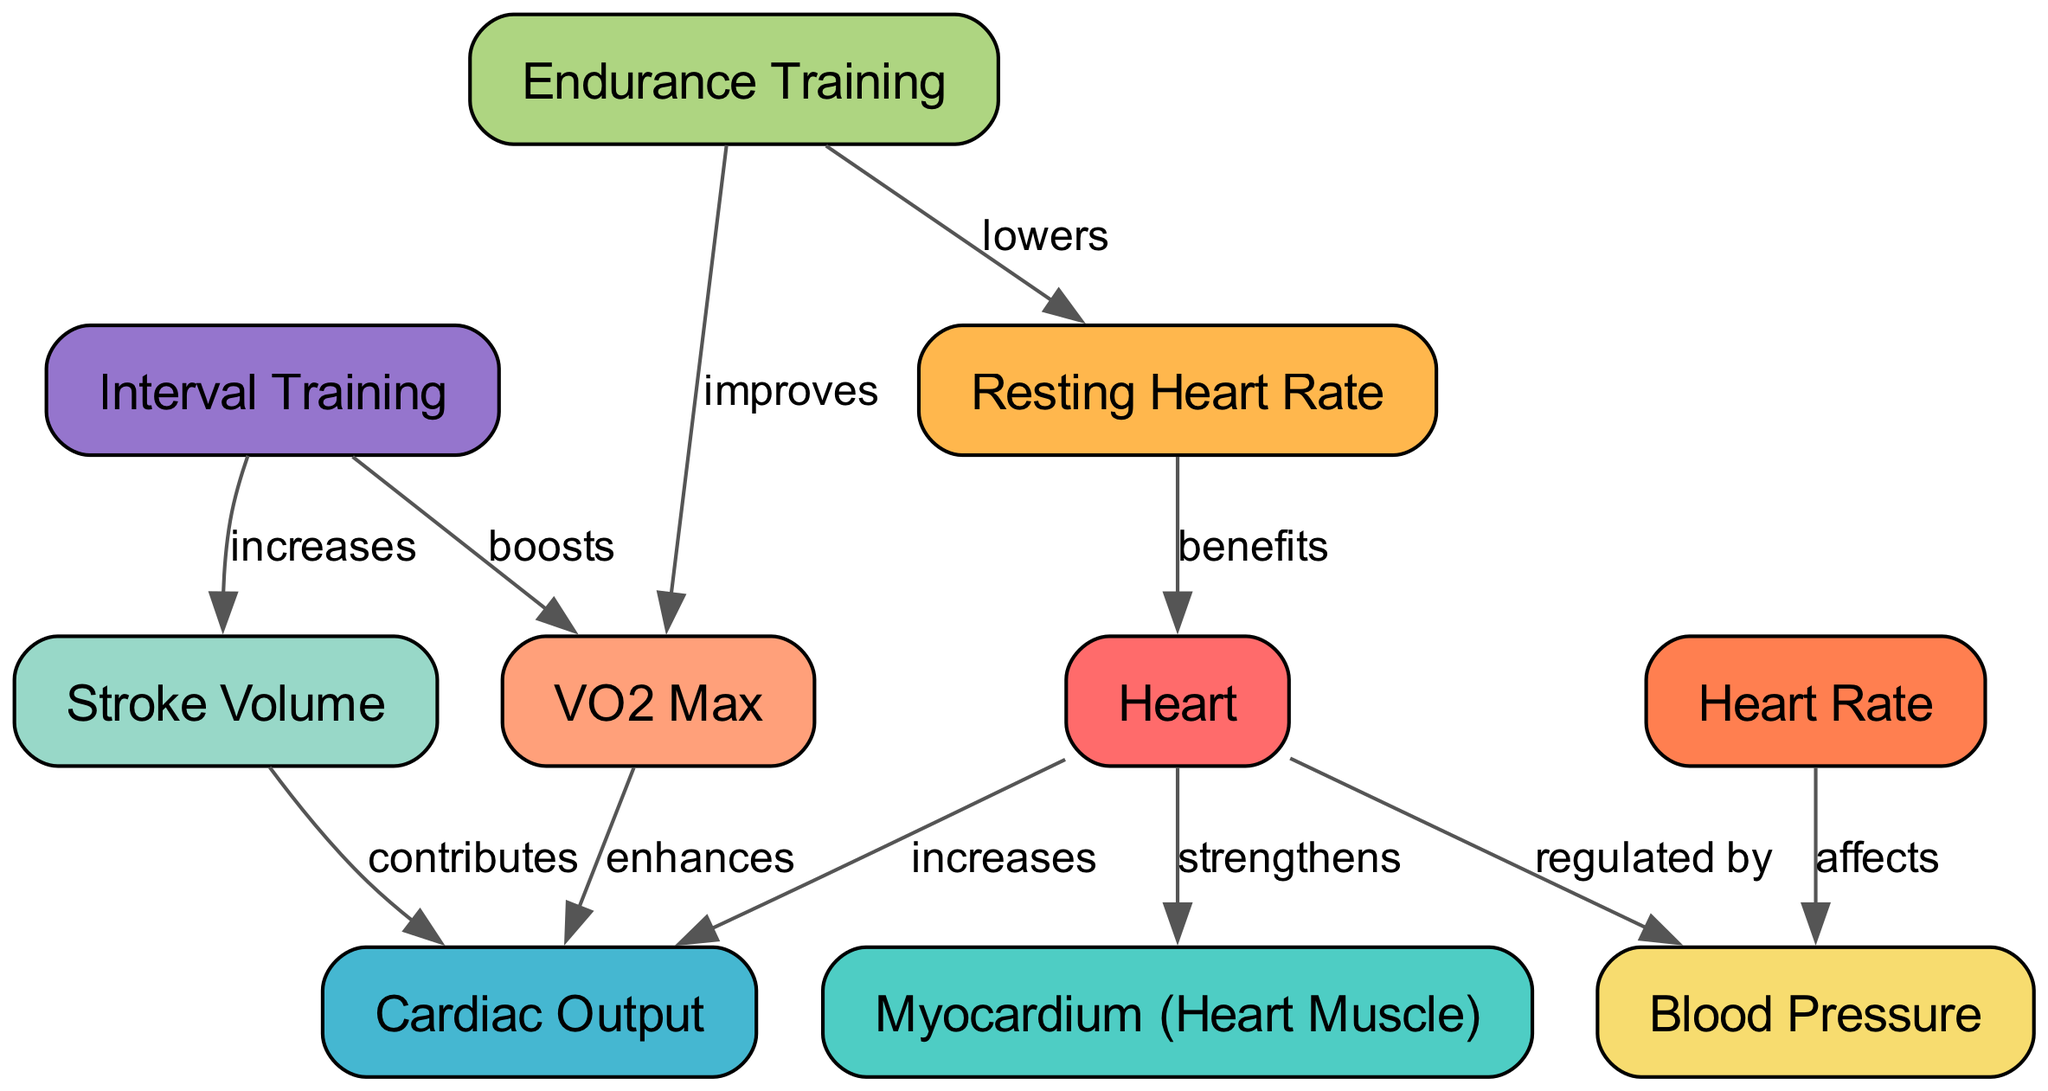What does exercise do to the myocardium? The diagram indicates that the Heart strengthens the Myocardium. So, exercise has a strengthening effect on the heart muscle.
Answer: strengthens How many nodes are present in the diagram? The total number of nodes in the diagram is ten, as we count them from the data provided.
Answer: 10 What impact does endurance training have on VO2 Max? The diagram shows that Endurance Training improves VO2 Max, indicating a positive effect of endurance activities on this measure of fitness.
Answer: improves How does interval training affect stroke volume? The diagram indicates that Interval Training increases Stroke Volume, illustrating that this type of exercise results in a higher volume of blood being pumped per heartbeat.
Answer: increases What is the relationship between heart rate and blood pressure? The diagram indicates that Heart Rate affects Blood Pressure, meaning changes in heart rate can influence blood pressure levels.
Answer: affects What benefits does a lower resting heart rate have? According to the diagram, a lower Resting Heart Rate benefits the Heart, suggesting that improved physical fitness may lead to a healthier heart function.
Answer: benefits What does the VO2 Max enhance in relation to cardiac output? The diagram states that VO2 Max enhances Cardiac Output, showing that a higher VO2 Max leads to better performance in terms of how much blood the heart can pump.
Answer: enhances What type of training lowers resting heart rate? The diagram clearly indicates that Endurance Training lowers Resting Heart Rate, suggesting that regular aerobic exercise contributes to a reduced resting heart rate over time.
Answer: lowers How does the heart regulate blood pressure? The diagram indicates that the Heart regulates Blood Pressure, indicating its essential role in maintaining stable pressure within the arterial system.
Answer: regulated by 